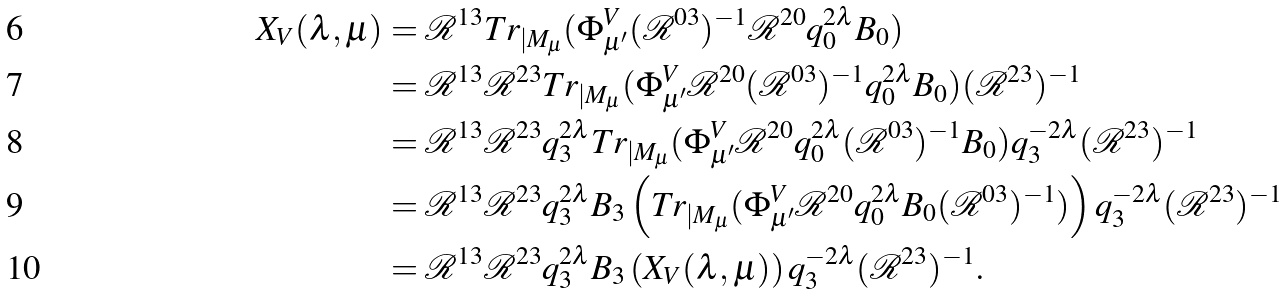<formula> <loc_0><loc_0><loc_500><loc_500>X _ { V } ( \lambda , \mu ) & = \mathcal { R } ^ { 1 3 } T r _ { | M _ { \mu } } ( \Phi _ { \mu ^ { \prime } } ^ { V } ( \mathcal { R } ^ { 0 3 } ) ^ { - 1 } \mathcal { R } ^ { 2 0 } q _ { 0 } ^ { 2 \lambda } B _ { 0 } ) \\ & = \mathcal { R } ^ { 1 3 } \mathcal { R } ^ { 2 3 } T r _ { | M _ { \mu } } ( \Phi _ { \mu ^ { \prime } } ^ { V } \mathcal { R } ^ { 2 0 } ( \mathcal { R } ^ { 0 3 } ) ^ { - 1 } q _ { 0 } ^ { 2 \lambda } B _ { 0 } ) ( \mathcal { R } ^ { 2 3 } ) ^ { - 1 } \\ & = \mathcal { R } ^ { 1 3 } \mathcal { R } ^ { 2 3 } q _ { 3 } ^ { 2 \lambda } T r _ { | M _ { \mu } } ( \Phi _ { \mu ^ { \prime } } ^ { V } \mathcal { R } ^ { 2 0 } q _ { 0 } ^ { 2 \lambda } ( \mathcal { R } ^ { 0 3 } ) ^ { - 1 } B _ { 0 } ) q _ { 3 } ^ { - 2 \lambda } ( \mathcal { R } ^ { 2 3 } ) ^ { - 1 } \\ & = \mathcal { R } ^ { 1 3 } \mathcal { R } ^ { 2 3 } q _ { 3 } ^ { 2 \lambda } B _ { 3 } \left ( T r _ { | M _ { \mu } } ( \Phi _ { \mu ^ { \prime } } ^ { V } \mathcal { R } ^ { 2 0 } q _ { 0 } ^ { 2 \lambda } B _ { 0 } ( \mathcal { R } ^ { 0 3 } ) ^ { - 1 } ) \right ) q _ { 3 } ^ { - 2 \lambda } ( \mathcal { R } ^ { 2 3 } ) ^ { - 1 } \\ & = \mathcal { R } ^ { 1 3 } \mathcal { R } ^ { 2 3 } q _ { 3 } ^ { 2 \lambda } B _ { 3 } \left ( X _ { V } ( \lambda , \mu ) \right ) q _ { 3 } ^ { - 2 \lambda } ( \mathcal { R } ^ { 2 3 } ) ^ { - 1 } .</formula> 